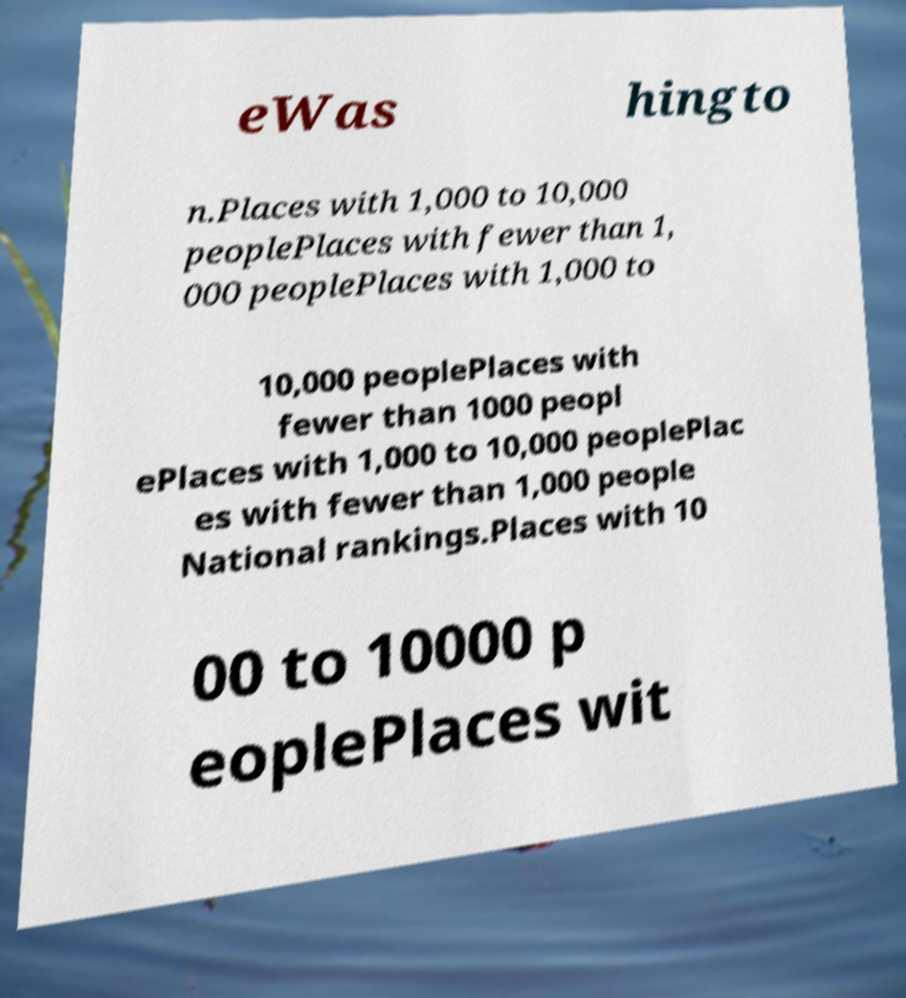Could you extract and type out the text from this image? eWas hingto n.Places with 1,000 to 10,000 peoplePlaces with fewer than 1, 000 peoplePlaces with 1,000 to 10,000 peoplePlaces with fewer than 1000 peopl ePlaces with 1,000 to 10,000 peoplePlac es with fewer than 1,000 people National rankings.Places with 10 00 to 10000 p eoplePlaces wit 